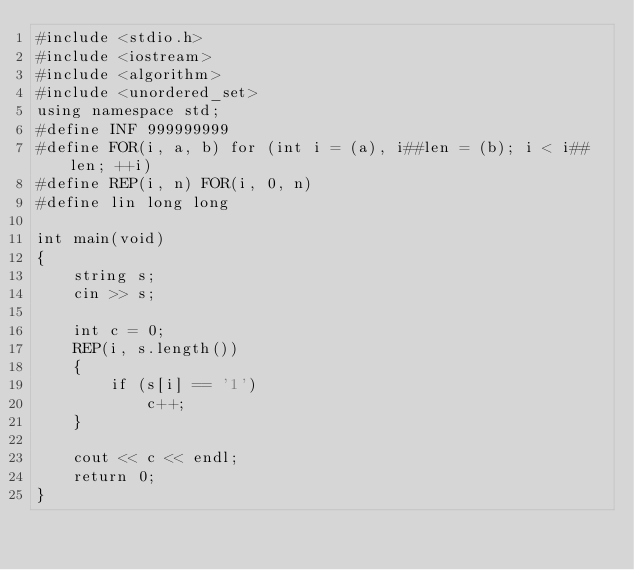Convert code to text. <code><loc_0><loc_0><loc_500><loc_500><_C++_>#include <stdio.h>
#include <iostream>
#include <algorithm>
#include <unordered_set>
using namespace std;
#define INF 999999999
#define FOR(i, a, b) for (int i = (a), i##len = (b); i < i##len; ++i)
#define REP(i, n) FOR(i, 0, n)
#define lin long long

int main(void)
{
    string s;
    cin >> s;

    int c = 0;
    REP(i, s.length())
    {
        if (s[i] == '1')
            c++;
    }

    cout << c << endl;
    return 0;
}
</code> 